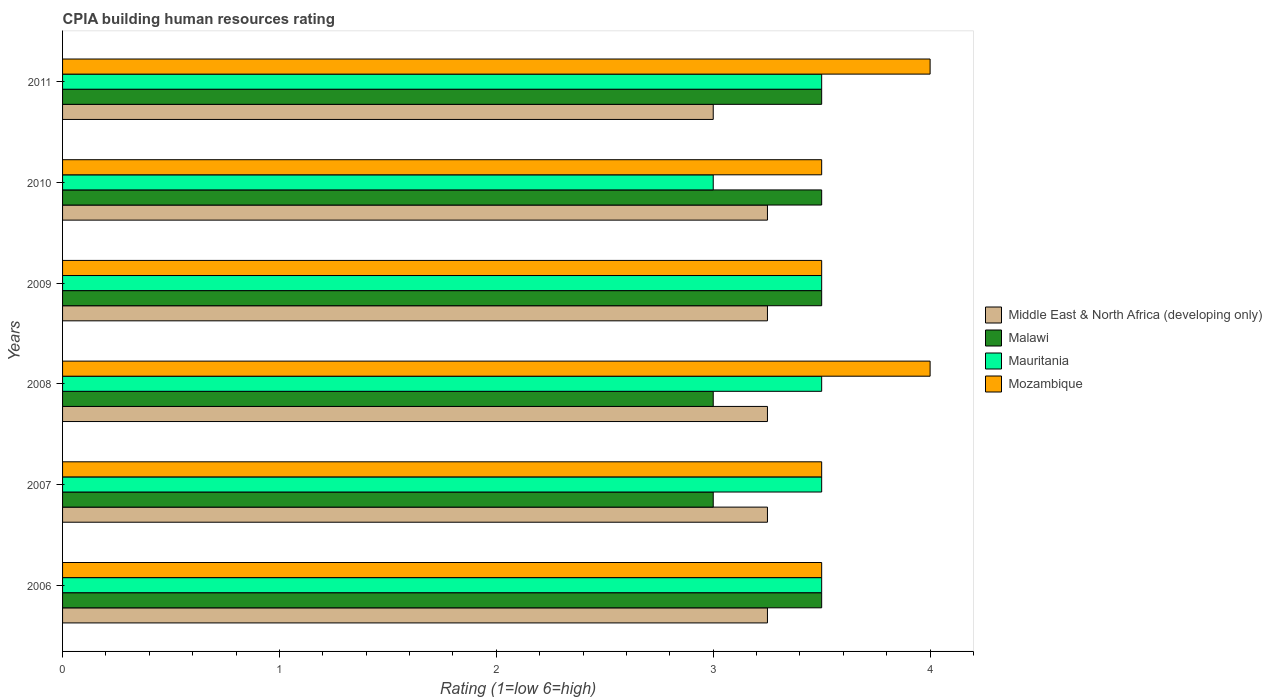How many groups of bars are there?
Provide a short and direct response. 6. How many bars are there on the 3rd tick from the bottom?
Your answer should be very brief. 4. What is the CPIA rating in Mauritania in 2008?
Keep it short and to the point. 3.5. Across all years, what is the maximum CPIA rating in Mauritania?
Make the answer very short. 3.5. In which year was the CPIA rating in Mauritania maximum?
Keep it short and to the point. 2006. In which year was the CPIA rating in Middle East & North Africa (developing only) minimum?
Provide a short and direct response. 2011. What is the total CPIA rating in Middle East & North Africa (developing only) in the graph?
Offer a very short reply. 19.25. What is the difference between the CPIA rating in Mozambique in 2008 and that in 2011?
Offer a terse response. 0. What is the difference between the CPIA rating in Mozambique in 2010 and the CPIA rating in Mauritania in 2008?
Provide a short and direct response. 0. What is the average CPIA rating in Malawi per year?
Provide a short and direct response. 3.33. In the year 2007, what is the difference between the CPIA rating in Mauritania and CPIA rating in Mozambique?
Provide a succinct answer. 0. What is the ratio of the CPIA rating in Mozambique in 2008 to that in 2011?
Your answer should be very brief. 1. What is the difference between the highest and the second highest CPIA rating in Middle East & North Africa (developing only)?
Your response must be concise. 0. In how many years, is the CPIA rating in Middle East & North Africa (developing only) greater than the average CPIA rating in Middle East & North Africa (developing only) taken over all years?
Make the answer very short. 5. Is the sum of the CPIA rating in Mauritania in 2009 and 2010 greater than the maximum CPIA rating in Malawi across all years?
Ensure brevity in your answer.  Yes. Is it the case that in every year, the sum of the CPIA rating in Malawi and CPIA rating in Middle East & North Africa (developing only) is greater than the sum of CPIA rating in Mozambique and CPIA rating in Mauritania?
Your answer should be very brief. No. What does the 2nd bar from the top in 2006 represents?
Your response must be concise. Mauritania. What does the 3rd bar from the bottom in 2008 represents?
Give a very brief answer. Mauritania. How many bars are there?
Provide a succinct answer. 24. What is the difference between two consecutive major ticks on the X-axis?
Provide a short and direct response. 1. Does the graph contain grids?
Your answer should be compact. No. How are the legend labels stacked?
Offer a terse response. Vertical. What is the title of the graph?
Make the answer very short. CPIA building human resources rating. What is the label or title of the X-axis?
Your response must be concise. Rating (1=low 6=high). What is the Rating (1=low 6=high) in Middle East & North Africa (developing only) in 2006?
Give a very brief answer. 3.25. What is the Rating (1=low 6=high) in Malawi in 2006?
Your response must be concise. 3.5. What is the Rating (1=low 6=high) in Middle East & North Africa (developing only) in 2007?
Give a very brief answer. 3.25. What is the Rating (1=low 6=high) of Mauritania in 2007?
Your answer should be very brief. 3.5. What is the Rating (1=low 6=high) in Middle East & North Africa (developing only) in 2008?
Give a very brief answer. 3.25. What is the Rating (1=low 6=high) of Malawi in 2009?
Your response must be concise. 3.5. What is the Rating (1=low 6=high) of Mozambique in 2009?
Provide a succinct answer. 3.5. What is the Rating (1=low 6=high) of Mauritania in 2010?
Make the answer very short. 3. What is the Rating (1=low 6=high) in Mauritania in 2011?
Ensure brevity in your answer.  3.5. Across all years, what is the maximum Rating (1=low 6=high) of Middle East & North Africa (developing only)?
Keep it short and to the point. 3.25. Across all years, what is the maximum Rating (1=low 6=high) in Mauritania?
Ensure brevity in your answer.  3.5. Across all years, what is the minimum Rating (1=low 6=high) of Mozambique?
Provide a succinct answer. 3.5. What is the total Rating (1=low 6=high) of Middle East & North Africa (developing only) in the graph?
Provide a succinct answer. 19.25. What is the difference between the Rating (1=low 6=high) in Malawi in 2006 and that in 2007?
Your response must be concise. 0.5. What is the difference between the Rating (1=low 6=high) in Mauritania in 2006 and that in 2007?
Make the answer very short. 0. What is the difference between the Rating (1=low 6=high) in Mozambique in 2006 and that in 2007?
Offer a very short reply. 0. What is the difference between the Rating (1=low 6=high) in Malawi in 2006 and that in 2008?
Make the answer very short. 0.5. What is the difference between the Rating (1=low 6=high) in Mauritania in 2006 and that in 2008?
Your answer should be compact. 0. What is the difference between the Rating (1=low 6=high) of Malawi in 2006 and that in 2009?
Provide a succinct answer. 0. What is the difference between the Rating (1=low 6=high) in Middle East & North Africa (developing only) in 2006 and that in 2010?
Offer a very short reply. 0. What is the difference between the Rating (1=low 6=high) in Middle East & North Africa (developing only) in 2006 and that in 2011?
Your answer should be very brief. 0.25. What is the difference between the Rating (1=low 6=high) of Mauritania in 2006 and that in 2011?
Offer a very short reply. 0. What is the difference between the Rating (1=low 6=high) of Mozambique in 2006 and that in 2011?
Provide a succinct answer. -0.5. What is the difference between the Rating (1=low 6=high) of Middle East & North Africa (developing only) in 2007 and that in 2008?
Your answer should be compact. 0. What is the difference between the Rating (1=low 6=high) in Malawi in 2007 and that in 2008?
Give a very brief answer. 0. What is the difference between the Rating (1=low 6=high) in Mozambique in 2007 and that in 2008?
Provide a short and direct response. -0.5. What is the difference between the Rating (1=low 6=high) of Middle East & North Africa (developing only) in 2007 and that in 2009?
Offer a very short reply. 0. What is the difference between the Rating (1=low 6=high) of Malawi in 2007 and that in 2009?
Make the answer very short. -0.5. What is the difference between the Rating (1=low 6=high) in Mauritania in 2007 and that in 2009?
Your answer should be compact. 0. What is the difference between the Rating (1=low 6=high) of Middle East & North Africa (developing only) in 2007 and that in 2011?
Make the answer very short. 0.25. What is the difference between the Rating (1=low 6=high) in Malawi in 2007 and that in 2011?
Your response must be concise. -0.5. What is the difference between the Rating (1=low 6=high) in Mozambique in 2007 and that in 2011?
Provide a succinct answer. -0.5. What is the difference between the Rating (1=low 6=high) of Malawi in 2008 and that in 2010?
Provide a succinct answer. -0.5. What is the difference between the Rating (1=low 6=high) of Mauritania in 2008 and that in 2010?
Offer a terse response. 0.5. What is the difference between the Rating (1=low 6=high) of Mozambique in 2008 and that in 2010?
Make the answer very short. 0.5. What is the difference between the Rating (1=low 6=high) in Malawi in 2008 and that in 2011?
Provide a succinct answer. -0.5. What is the difference between the Rating (1=low 6=high) in Mauritania in 2008 and that in 2011?
Your response must be concise. 0. What is the difference between the Rating (1=low 6=high) of Middle East & North Africa (developing only) in 2009 and that in 2010?
Your response must be concise. 0. What is the difference between the Rating (1=low 6=high) of Malawi in 2009 and that in 2010?
Ensure brevity in your answer.  0. What is the difference between the Rating (1=low 6=high) of Middle East & North Africa (developing only) in 2009 and that in 2011?
Keep it short and to the point. 0.25. What is the difference between the Rating (1=low 6=high) of Malawi in 2009 and that in 2011?
Offer a terse response. 0. What is the difference between the Rating (1=low 6=high) in Mauritania in 2009 and that in 2011?
Your answer should be compact. 0. What is the difference between the Rating (1=low 6=high) in Mozambique in 2009 and that in 2011?
Provide a short and direct response. -0.5. What is the difference between the Rating (1=low 6=high) in Malawi in 2010 and that in 2011?
Keep it short and to the point. 0. What is the difference between the Rating (1=low 6=high) in Mauritania in 2010 and that in 2011?
Provide a short and direct response. -0.5. What is the difference between the Rating (1=low 6=high) of Mozambique in 2010 and that in 2011?
Give a very brief answer. -0.5. What is the difference between the Rating (1=low 6=high) of Middle East & North Africa (developing only) in 2006 and the Rating (1=low 6=high) of Malawi in 2008?
Provide a short and direct response. 0.25. What is the difference between the Rating (1=low 6=high) of Middle East & North Africa (developing only) in 2006 and the Rating (1=low 6=high) of Mauritania in 2008?
Your answer should be compact. -0.25. What is the difference between the Rating (1=low 6=high) of Middle East & North Africa (developing only) in 2006 and the Rating (1=low 6=high) of Mozambique in 2008?
Give a very brief answer. -0.75. What is the difference between the Rating (1=low 6=high) of Malawi in 2006 and the Rating (1=low 6=high) of Mozambique in 2008?
Your answer should be compact. -0.5. What is the difference between the Rating (1=low 6=high) of Mauritania in 2006 and the Rating (1=low 6=high) of Mozambique in 2008?
Keep it short and to the point. -0.5. What is the difference between the Rating (1=low 6=high) of Middle East & North Africa (developing only) in 2006 and the Rating (1=low 6=high) of Malawi in 2009?
Give a very brief answer. -0.25. What is the difference between the Rating (1=low 6=high) in Middle East & North Africa (developing only) in 2006 and the Rating (1=low 6=high) in Mauritania in 2009?
Ensure brevity in your answer.  -0.25. What is the difference between the Rating (1=low 6=high) of Malawi in 2006 and the Rating (1=low 6=high) of Mauritania in 2009?
Provide a short and direct response. 0. What is the difference between the Rating (1=low 6=high) of Malawi in 2006 and the Rating (1=low 6=high) of Mozambique in 2009?
Your response must be concise. 0. What is the difference between the Rating (1=low 6=high) of Mauritania in 2006 and the Rating (1=low 6=high) of Mozambique in 2009?
Give a very brief answer. 0. What is the difference between the Rating (1=low 6=high) of Middle East & North Africa (developing only) in 2006 and the Rating (1=low 6=high) of Malawi in 2010?
Give a very brief answer. -0.25. What is the difference between the Rating (1=low 6=high) in Middle East & North Africa (developing only) in 2006 and the Rating (1=low 6=high) in Mauritania in 2010?
Make the answer very short. 0.25. What is the difference between the Rating (1=low 6=high) in Malawi in 2006 and the Rating (1=low 6=high) in Mozambique in 2010?
Keep it short and to the point. 0. What is the difference between the Rating (1=low 6=high) in Middle East & North Africa (developing only) in 2006 and the Rating (1=low 6=high) in Malawi in 2011?
Offer a very short reply. -0.25. What is the difference between the Rating (1=low 6=high) of Middle East & North Africa (developing only) in 2006 and the Rating (1=low 6=high) of Mauritania in 2011?
Ensure brevity in your answer.  -0.25. What is the difference between the Rating (1=low 6=high) in Middle East & North Africa (developing only) in 2006 and the Rating (1=low 6=high) in Mozambique in 2011?
Ensure brevity in your answer.  -0.75. What is the difference between the Rating (1=low 6=high) of Malawi in 2006 and the Rating (1=low 6=high) of Mauritania in 2011?
Your response must be concise. 0. What is the difference between the Rating (1=low 6=high) in Malawi in 2006 and the Rating (1=low 6=high) in Mozambique in 2011?
Offer a very short reply. -0.5. What is the difference between the Rating (1=low 6=high) in Middle East & North Africa (developing only) in 2007 and the Rating (1=low 6=high) in Malawi in 2008?
Your answer should be compact. 0.25. What is the difference between the Rating (1=low 6=high) in Middle East & North Africa (developing only) in 2007 and the Rating (1=low 6=high) in Mozambique in 2008?
Your response must be concise. -0.75. What is the difference between the Rating (1=low 6=high) of Malawi in 2007 and the Rating (1=low 6=high) of Mauritania in 2008?
Make the answer very short. -0.5. What is the difference between the Rating (1=low 6=high) in Malawi in 2007 and the Rating (1=low 6=high) in Mozambique in 2008?
Your answer should be very brief. -1. What is the difference between the Rating (1=low 6=high) in Middle East & North Africa (developing only) in 2007 and the Rating (1=low 6=high) in Malawi in 2009?
Your response must be concise. -0.25. What is the difference between the Rating (1=low 6=high) in Middle East & North Africa (developing only) in 2007 and the Rating (1=low 6=high) in Mozambique in 2009?
Give a very brief answer. -0.25. What is the difference between the Rating (1=low 6=high) in Mauritania in 2007 and the Rating (1=low 6=high) in Mozambique in 2009?
Offer a very short reply. 0. What is the difference between the Rating (1=low 6=high) in Malawi in 2007 and the Rating (1=low 6=high) in Mauritania in 2010?
Offer a terse response. 0. What is the difference between the Rating (1=low 6=high) of Middle East & North Africa (developing only) in 2007 and the Rating (1=low 6=high) of Mozambique in 2011?
Your answer should be compact. -0.75. What is the difference between the Rating (1=low 6=high) of Malawi in 2007 and the Rating (1=low 6=high) of Mauritania in 2011?
Keep it short and to the point. -0.5. What is the difference between the Rating (1=low 6=high) of Middle East & North Africa (developing only) in 2008 and the Rating (1=low 6=high) of Mozambique in 2009?
Make the answer very short. -0.25. What is the difference between the Rating (1=low 6=high) of Malawi in 2008 and the Rating (1=low 6=high) of Mauritania in 2009?
Offer a very short reply. -0.5. What is the difference between the Rating (1=low 6=high) in Malawi in 2008 and the Rating (1=low 6=high) in Mozambique in 2009?
Make the answer very short. -0.5. What is the difference between the Rating (1=low 6=high) in Mauritania in 2008 and the Rating (1=low 6=high) in Mozambique in 2009?
Provide a short and direct response. 0. What is the difference between the Rating (1=low 6=high) in Middle East & North Africa (developing only) in 2008 and the Rating (1=low 6=high) in Malawi in 2010?
Make the answer very short. -0.25. What is the difference between the Rating (1=low 6=high) in Middle East & North Africa (developing only) in 2008 and the Rating (1=low 6=high) in Mauritania in 2010?
Your answer should be compact. 0.25. What is the difference between the Rating (1=low 6=high) of Middle East & North Africa (developing only) in 2008 and the Rating (1=low 6=high) of Mozambique in 2011?
Ensure brevity in your answer.  -0.75. What is the difference between the Rating (1=low 6=high) of Mauritania in 2008 and the Rating (1=low 6=high) of Mozambique in 2011?
Make the answer very short. -0.5. What is the difference between the Rating (1=low 6=high) in Middle East & North Africa (developing only) in 2009 and the Rating (1=low 6=high) in Mauritania in 2010?
Keep it short and to the point. 0.25. What is the difference between the Rating (1=low 6=high) in Malawi in 2009 and the Rating (1=low 6=high) in Mauritania in 2010?
Provide a short and direct response. 0.5. What is the difference between the Rating (1=low 6=high) in Middle East & North Africa (developing only) in 2009 and the Rating (1=low 6=high) in Malawi in 2011?
Make the answer very short. -0.25. What is the difference between the Rating (1=low 6=high) in Middle East & North Africa (developing only) in 2009 and the Rating (1=low 6=high) in Mauritania in 2011?
Provide a short and direct response. -0.25. What is the difference between the Rating (1=low 6=high) in Middle East & North Africa (developing only) in 2009 and the Rating (1=low 6=high) in Mozambique in 2011?
Your answer should be compact. -0.75. What is the difference between the Rating (1=low 6=high) in Malawi in 2009 and the Rating (1=low 6=high) in Mauritania in 2011?
Give a very brief answer. 0. What is the difference between the Rating (1=low 6=high) of Malawi in 2009 and the Rating (1=low 6=high) of Mozambique in 2011?
Keep it short and to the point. -0.5. What is the difference between the Rating (1=low 6=high) of Middle East & North Africa (developing only) in 2010 and the Rating (1=low 6=high) of Mauritania in 2011?
Offer a terse response. -0.25. What is the difference between the Rating (1=low 6=high) in Middle East & North Africa (developing only) in 2010 and the Rating (1=low 6=high) in Mozambique in 2011?
Your answer should be very brief. -0.75. What is the difference between the Rating (1=low 6=high) in Malawi in 2010 and the Rating (1=low 6=high) in Mauritania in 2011?
Ensure brevity in your answer.  0. What is the difference between the Rating (1=low 6=high) of Malawi in 2010 and the Rating (1=low 6=high) of Mozambique in 2011?
Keep it short and to the point. -0.5. What is the average Rating (1=low 6=high) in Middle East & North Africa (developing only) per year?
Keep it short and to the point. 3.21. What is the average Rating (1=low 6=high) of Malawi per year?
Provide a short and direct response. 3.33. What is the average Rating (1=low 6=high) in Mauritania per year?
Your response must be concise. 3.42. What is the average Rating (1=low 6=high) of Mozambique per year?
Make the answer very short. 3.67. In the year 2006, what is the difference between the Rating (1=low 6=high) of Middle East & North Africa (developing only) and Rating (1=low 6=high) of Mauritania?
Make the answer very short. -0.25. In the year 2006, what is the difference between the Rating (1=low 6=high) of Middle East & North Africa (developing only) and Rating (1=low 6=high) of Mozambique?
Provide a short and direct response. -0.25. In the year 2006, what is the difference between the Rating (1=low 6=high) in Malawi and Rating (1=low 6=high) in Mauritania?
Keep it short and to the point. 0. In the year 2006, what is the difference between the Rating (1=low 6=high) of Mauritania and Rating (1=low 6=high) of Mozambique?
Ensure brevity in your answer.  0. In the year 2007, what is the difference between the Rating (1=low 6=high) of Middle East & North Africa (developing only) and Rating (1=low 6=high) of Malawi?
Give a very brief answer. 0.25. In the year 2007, what is the difference between the Rating (1=low 6=high) of Malawi and Rating (1=low 6=high) of Mauritania?
Make the answer very short. -0.5. In the year 2007, what is the difference between the Rating (1=low 6=high) of Mauritania and Rating (1=low 6=high) of Mozambique?
Your response must be concise. 0. In the year 2008, what is the difference between the Rating (1=low 6=high) in Middle East & North Africa (developing only) and Rating (1=low 6=high) in Malawi?
Offer a very short reply. 0.25. In the year 2008, what is the difference between the Rating (1=low 6=high) of Middle East & North Africa (developing only) and Rating (1=low 6=high) of Mozambique?
Make the answer very short. -0.75. In the year 2008, what is the difference between the Rating (1=low 6=high) of Malawi and Rating (1=low 6=high) of Mauritania?
Provide a succinct answer. -0.5. In the year 2008, what is the difference between the Rating (1=low 6=high) of Malawi and Rating (1=low 6=high) of Mozambique?
Your answer should be compact. -1. In the year 2009, what is the difference between the Rating (1=low 6=high) of Middle East & North Africa (developing only) and Rating (1=low 6=high) of Malawi?
Your answer should be compact. -0.25. In the year 2009, what is the difference between the Rating (1=low 6=high) of Malawi and Rating (1=low 6=high) of Mozambique?
Offer a terse response. 0. In the year 2009, what is the difference between the Rating (1=low 6=high) in Mauritania and Rating (1=low 6=high) in Mozambique?
Give a very brief answer. 0. In the year 2010, what is the difference between the Rating (1=low 6=high) of Middle East & North Africa (developing only) and Rating (1=low 6=high) of Malawi?
Make the answer very short. -0.25. In the year 2011, what is the difference between the Rating (1=low 6=high) of Middle East & North Africa (developing only) and Rating (1=low 6=high) of Mozambique?
Offer a terse response. -1. In the year 2011, what is the difference between the Rating (1=low 6=high) of Malawi and Rating (1=low 6=high) of Mauritania?
Provide a succinct answer. 0. What is the ratio of the Rating (1=low 6=high) in Malawi in 2006 to that in 2007?
Keep it short and to the point. 1.17. What is the ratio of the Rating (1=low 6=high) in Middle East & North Africa (developing only) in 2006 to that in 2008?
Offer a very short reply. 1. What is the ratio of the Rating (1=low 6=high) of Malawi in 2006 to that in 2008?
Keep it short and to the point. 1.17. What is the ratio of the Rating (1=low 6=high) in Malawi in 2006 to that in 2009?
Keep it short and to the point. 1. What is the ratio of the Rating (1=low 6=high) in Mozambique in 2006 to that in 2009?
Your response must be concise. 1. What is the ratio of the Rating (1=low 6=high) of Mozambique in 2006 to that in 2011?
Provide a succinct answer. 0.88. What is the ratio of the Rating (1=low 6=high) in Malawi in 2007 to that in 2008?
Provide a succinct answer. 1. What is the ratio of the Rating (1=low 6=high) of Mozambique in 2007 to that in 2008?
Your answer should be compact. 0.88. What is the ratio of the Rating (1=low 6=high) in Middle East & North Africa (developing only) in 2007 to that in 2010?
Your response must be concise. 1. What is the ratio of the Rating (1=low 6=high) in Malawi in 2007 to that in 2010?
Offer a very short reply. 0.86. What is the ratio of the Rating (1=low 6=high) of Mozambique in 2007 to that in 2010?
Your response must be concise. 1. What is the ratio of the Rating (1=low 6=high) in Mozambique in 2007 to that in 2011?
Provide a short and direct response. 0.88. What is the ratio of the Rating (1=low 6=high) of Middle East & North Africa (developing only) in 2008 to that in 2009?
Ensure brevity in your answer.  1. What is the ratio of the Rating (1=low 6=high) of Malawi in 2008 to that in 2009?
Make the answer very short. 0.86. What is the ratio of the Rating (1=low 6=high) in Mauritania in 2008 to that in 2009?
Your answer should be compact. 1. What is the ratio of the Rating (1=low 6=high) in Malawi in 2008 to that in 2010?
Make the answer very short. 0.86. What is the ratio of the Rating (1=low 6=high) in Mozambique in 2008 to that in 2011?
Provide a succinct answer. 1. What is the ratio of the Rating (1=low 6=high) in Middle East & North Africa (developing only) in 2009 to that in 2010?
Offer a terse response. 1. What is the ratio of the Rating (1=low 6=high) of Mauritania in 2009 to that in 2010?
Your answer should be compact. 1.17. What is the ratio of the Rating (1=low 6=high) of Middle East & North Africa (developing only) in 2009 to that in 2011?
Give a very brief answer. 1.08. What is the ratio of the Rating (1=low 6=high) of Middle East & North Africa (developing only) in 2010 to that in 2011?
Provide a short and direct response. 1.08. What is the ratio of the Rating (1=low 6=high) in Malawi in 2010 to that in 2011?
Your answer should be very brief. 1. What is the ratio of the Rating (1=low 6=high) in Mauritania in 2010 to that in 2011?
Your answer should be compact. 0.86. What is the difference between the highest and the second highest Rating (1=low 6=high) in Mozambique?
Your response must be concise. 0. What is the difference between the highest and the lowest Rating (1=low 6=high) of Malawi?
Provide a succinct answer. 0.5. What is the difference between the highest and the lowest Rating (1=low 6=high) of Mozambique?
Your response must be concise. 0.5. 